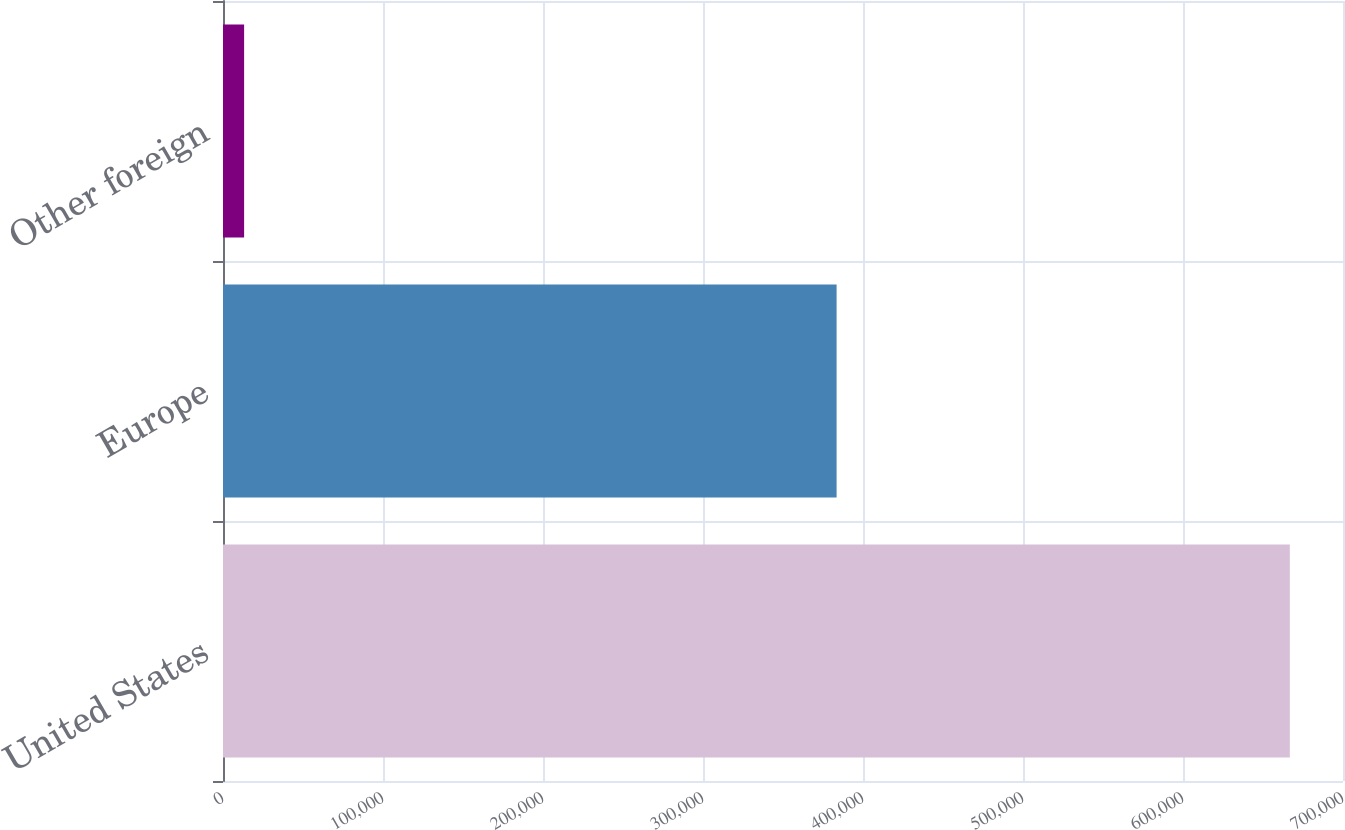<chart> <loc_0><loc_0><loc_500><loc_500><bar_chart><fcel>United States<fcel>Europe<fcel>Other foreign<nl><fcel>666759<fcel>383501<fcel>13197<nl></chart> 